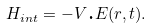Convert formula to latex. <formula><loc_0><loc_0><loc_500><loc_500>H _ { i n t } = - V \text {.} E ( r , t ) .</formula> 